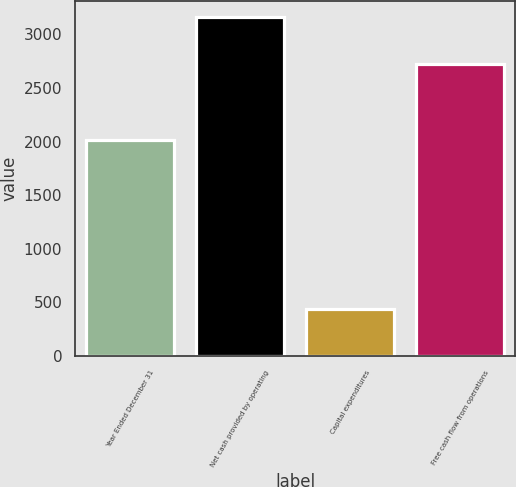<chart> <loc_0><loc_0><loc_500><loc_500><bar_chart><fcel>Year Ended December 31<fcel>Net cash provided by operating<fcel>Capital expenditures<fcel>Free cash flow from operations<nl><fcel>2013<fcel>3159<fcel>436<fcel>2723<nl></chart> 